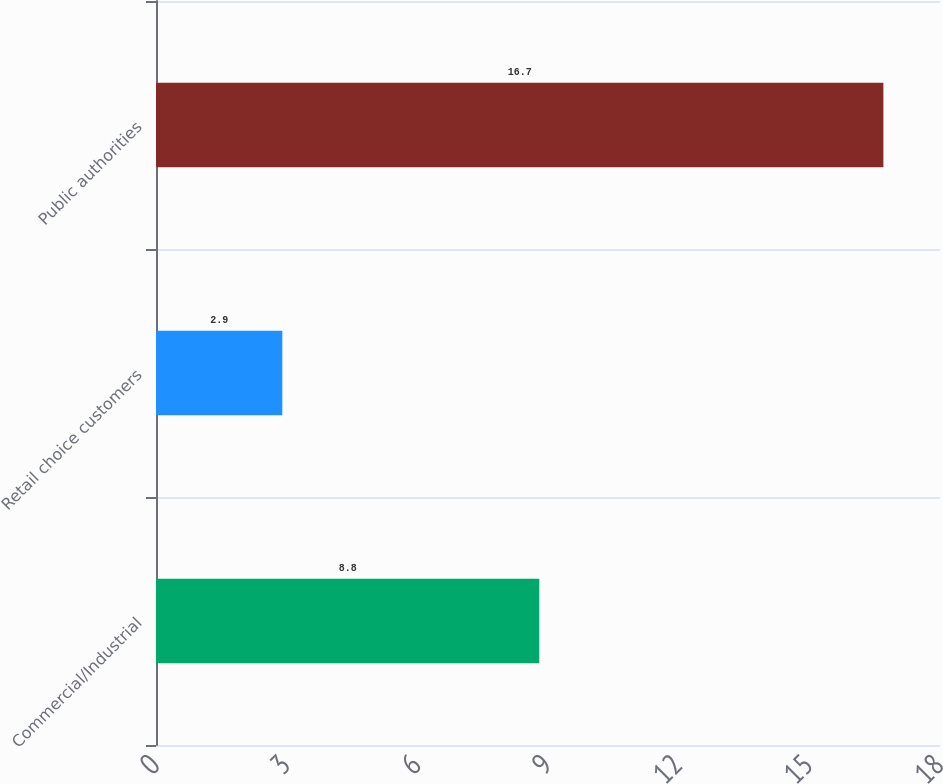Convert chart to OTSL. <chart><loc_0><loc_0><loc_500><loc_500><bar_chart><fcel>Commercial/Industrial<fcel>Retail choice customers<fcel>Public authorities<nl><fcel>8.8<fcel>2.9<fcel>16.7<nl></chart> 